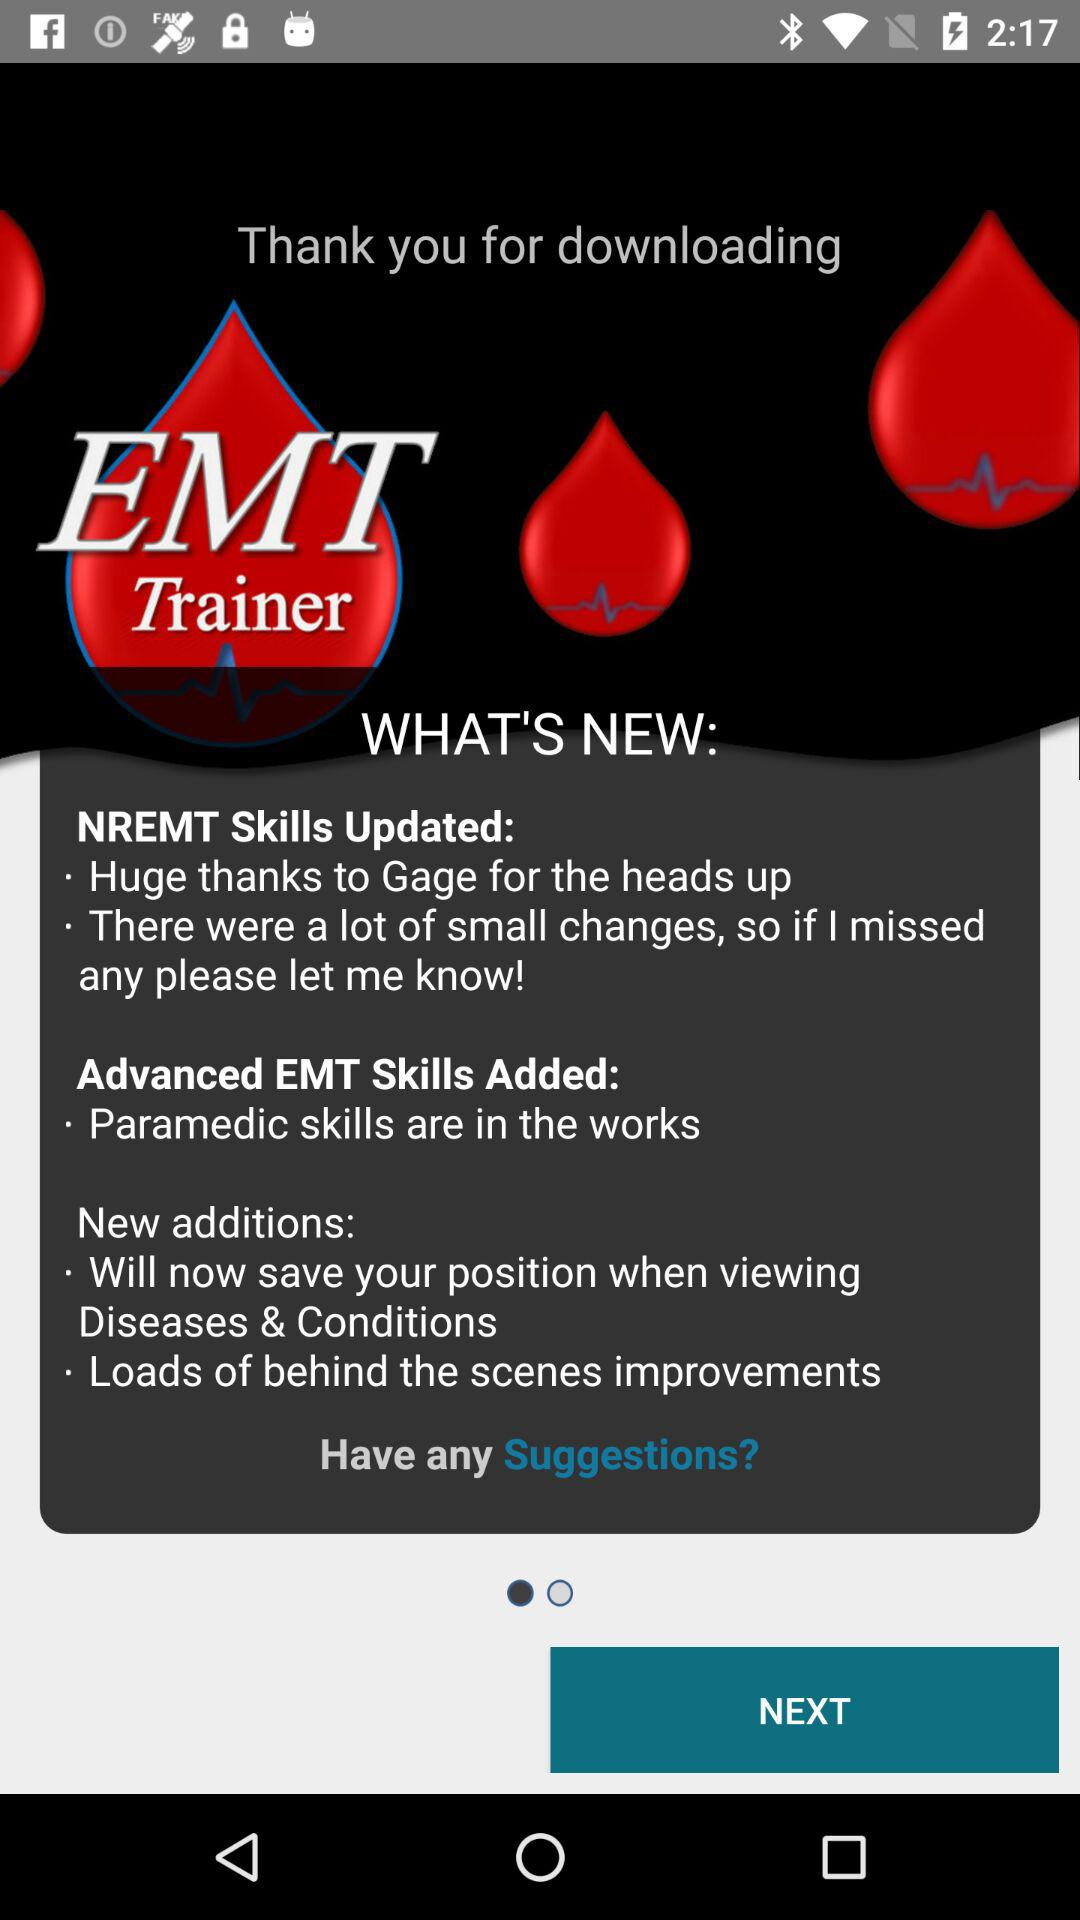What are the new additions to "EMT Trainer"? The new additions to "EMT Trainer" are "Will now save your position when viewing Diseases & Conditions" and "Loads of behind the scenes improvements". 